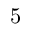Convert formula to latex. <formula><loc_0><loc_0><loc_500><loc_500>5</formula> 